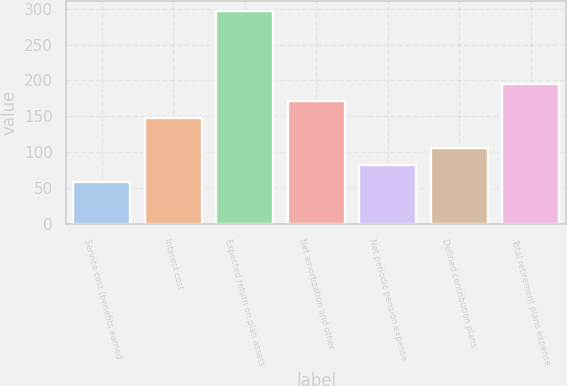Convert chart to OTSL. <chart><loc_0><loc_0><loc_500><loc_500><bar_chart><fcel>Service cost (benefits earned<fcel>Interest cost<fcel>Expected return on plan assets<fcel>Net amortization and other<fcel>Net periodic pension expense<fcel>Defined contribution plans<fcel>Total retirement plans expense<nl><fcel>59<fcel>148<fcel>296<fcel>171.7<fcel>82.7<fcel>106.4<fcel>195.4<nl></chart> 